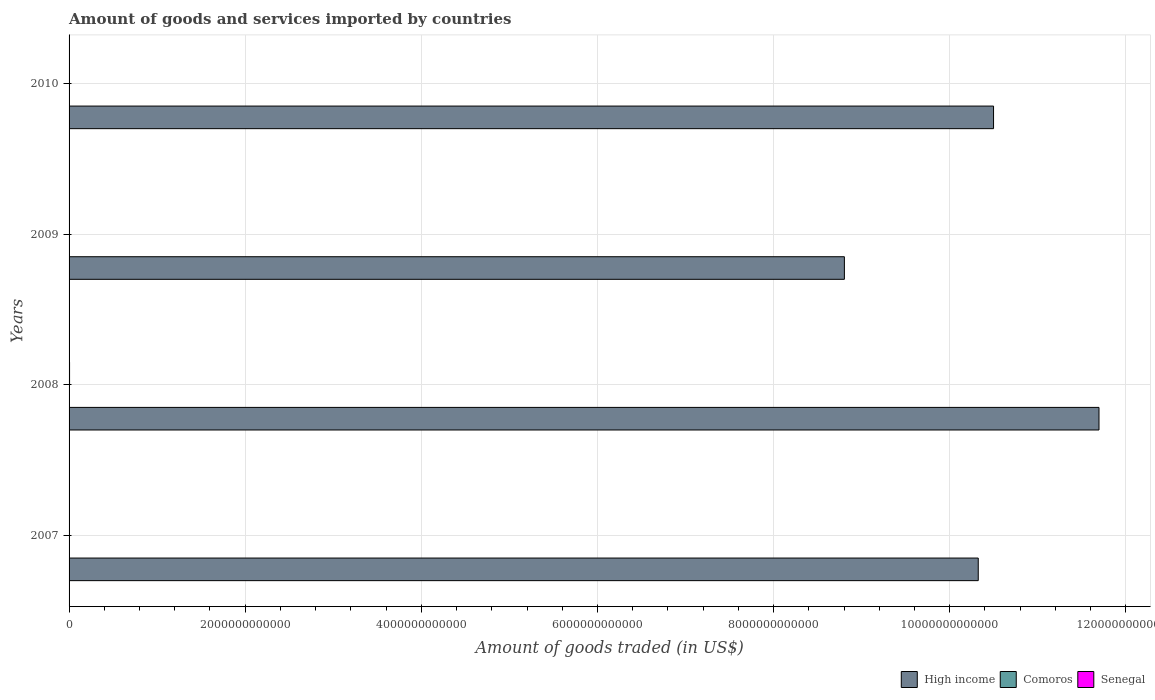How many groups of bars are there?
Provide a succinct answer. 4. Are the number of bars per tick equal to the number of legend labels?
Offer a terse response. Yes. How many bars are there on the 2nd tick from the top?
Make the answer very short. 3. What is the label of the 3rd group of bars from the top?
Provide a short and direct response. 2008. What is the total amount of goods and services imported in Comoros in 2010?
Offer a very short reply. 1.77e+08. Across all years, what is the maximum total amount of goods and services imported in High income?
Ensure brevity in your answer.  1.17e+13. Across all years, what is the minimum total amount of goods and services imported in Senegal?
Give a very brief answer. 4.08e+09. What is the total total amount of goods and services imported in High income in the graph?
Give a very brief answer. 4.13e+13. What is the difference between the total amount of goods and services imported in Senegal in 2007 and that in 2009?
Your response must be concise. 3.09e+07. What is the difference between the total amount of goods and services imported in Senegal in 2008 and the total amount of goods and services imported in Comoros in 2007?
Offer a terse response. 5.47e+09. What is the average total amount of goods and services imported in Senegal per year?
Provide a succinct answer. 4.49e+09. In the year 2008, what is the difference between the total amount of goods and services imported in Senegal and total amount of goods and services imported in High income?
Make the answer very short. -1.17e+13. What is the ratio of the total amount of goods and services imported in Comoros in 2008 to that in 2010?
Keep it short and to the point. 0.99. Is the total amount of goods and services imported in Senegal in 2007 less than that in 2009?
Offer a very short reply. No. What is the difference between the highest and the second highest total amount of goods and services imported in High income?
Keep it short and to the point. 1.20e+12. What is the difference between the highest and the lowest total amount of goods and services imported in Senegal?
Keep it short and to the point. 1.51e+09. In how many years, is the total amount of goods and services imported in Senegal greater than the average total amount of goods and services imported in Senegal taken over all years?
Ensure brevity in your answer.  1. Is the sum of the total amount of goods and services imported in Comoros in 2008 and 2010 greater than the maximum total amount of goods and services imported in Senegal across all years?
Provide a short and direct response. No. What does the 3rd bar from the top in 2010 represents?
Give a very brief answer. High income. How many bars are there?
Ensure brevity in your answer.  12. Are all the bars in the graph horizontal?
Your answer should be very brief. Yes. How many years are there in the graph?
Your answer should be compact. 4. What is the difference between two consecutive major ticks on the X-axis?
Your response must be concise. 2.00e+12. Are the values on the major ticks of X-axis written in scientific E-notation?
Give a very brief answer. No. Does the graph contain any zero values?
Your answer should be compact. No. Where does the legend appear in the graph?
Make the answer very short. Bottom right. How many legend labels are there?
Provide a succinct answer. 3. How are the legend labels stacked?
Your answer should be very brief. Horizontal. What is the title of the graph?
Keep it short and to the point. Amount of goods and services imported by countries. What is the label or title of the X-axis?
Give a very brief answer. Amount of goods traded (in US$). What is the label or title of the Y-axis?
Provide a succinct answer. Years. What is the Amount of goods traded (in US$) of High income in 2007?
Give a very brief answer. 1.03e+13. What is the Amount of goods traded (in US$) in Comoros in 2007?
Your answer should be compact. 1.28e+08. What is the Amount of goods traded (in US$) of Senegal in 2007?
Your response must be concise. 4.15e+09. What is the Amount of goods traded (in US$) in High income in 2008?
Your answer should be very brief. 1.17e+13. What is the Amount of goods traded (in US$) in Comoros in 2008?
Give a very brief answer. 1.76e+08. What is the Amount of goods traded (in US$) in Senegal in 2008?
Ensure brevity in your answer.  5.60e+09. What is the Amount of goods traded (in US$) of High income in 2009?
Give a very brief answer. 8.80e+12. What is the Amount of goods traded (in US$) in Comoros in 2009?
Your response must be concise. 1.70e+08. What is the Amount of goods traded (in US$) of Senegal in 2009?
Ensure brevity in your answer.  4.12e+09. What is the Amount of goods traded (in US$) of High income in 2010?
Your answer should be compact. 1.05e+13. What is the Amount of goods traded (in US$) in Comoros in 2010?
Your answer should be compact. 1.77e+08. What is the Amount of goods traded (in US$) of Senegal in 2010?
Keep it short and to the point. 4.08e+09. Across all years, what is the maximum Amount of goods traded (in US$) in High income?
Ensure brevity in your answer.  1.17e+13. Across all years, what is the maximum Amount of goods traded (in US$) of Comoros?
Your answer should be compact. 1.77e+08. Across all years, what is the maximum Amount of goods traded (in US$) of Senegal?
Your answer should be very brief. 5.60e+09. Across all years, what is the minimum Amount of goods traded (in US$) of High income?
Keep it short and to the point. 8.80e+12. Across all years, what is the minimum Amount of goods traded (in US$) of Comoros?
Provide a short and direct response. 1.28e+08. Across all years, what is the minimum Amount of goods traded (in US$) in Senegal?
Your answer should be compact. 4.08e+09. What is the total Amount of goods traded (in US$) of High income in the graph?
Offer a terse response. 4.13e+13. What is the total Amount of goods traded (in US$) of Comoros in the graph?
Make the answer very short. 6.51e+08. What is the total Amount of goods traded (in US$) in Senegal in the graph?
Provide a short and direct response. 1.80e+1. What is the difference between the Amount of goods traded (in US$) of High income in 2007 and that in 2008?
Provide a succinct answer. -1.37e+12. What is the difference between the Amount of goods traded (in US$) in Comoros in 2007 and that in 2008?
Give a very brief answer. -4.80e+07. What is the difference between the Amount of goods traded (in US$) in Senegal in 2007 and that in 2008?
Offer a very short reply. -1.44e+09. What is the difference between the Amount of goods traded (in US$) in High income in 2007 and that in 2009?
Provide a short and direct response. 1.52e+12. What is the difference between the Amount of goods traded (in US$) of Comoros in 2007 and that in 2009?
Your answer should be very brief. -4.17e+07. What is the difference between the Amount of goods traded (in US$) in Senegal in 2007 and that in 2009?
Your response must be concise. 3.09e+07. What is the difference between the Amount of goods traded (in US$) in High income in 2007 and that in 2010?
Provide a succinct answer. -1.74e+11. What is the difference between the Amount of goods traded (in US$) of Comoros in 2007 and that in 2010?
Offer a terse response. -4.95e+07. What is the difference between the Amount of goods traded (in US$) of Senegal in 2007 and that in 2010?
Your response must be concise. 7.14e+07. What is the difference between the Amount of goods traded (in US$) of High income in 2008 and that in 2009?
Give a very brief answer. 2.89e+12. What is the difference between the Amount of goods traded (in US$) of Comoros in 2008 and that in 2009?
Ensure brevity in your answer.  6.33e+06. What is the difference between the Amount of goods traded (in US$) in Senegal in 2008 and that in 2009?
Ensure brevity in your answer.  1.47e+09. What is the difference between the Amount of goods traded (in US$) in High income in 2008 and that in 2010?
Make the answer very short. 1.20e+12. What is the difference between the Amount of goods traded (in US$) of Comoros in 2008 and that in 2010?
Provide a succinct answer. -1.45e+06. What is the difference between the Amount of goods traded (in US$) in Senegal in 2008 and that in 2010?
Offer a terse response. 1.51e+09. What is the difference between the Amount of goods traded (in US$) of High income in 2009 and that in 2010?
Ensure brevity in your answer.  -1.69e+12. What is the difference between the Amount of goods traded (in US$) of Comoros in 2009 and that in 2010?
Give a very brief answer. -7.79e+06. What is the difference between the Amount of goods traded (in US$) in Senegal in 2009 and that in 2010?
Keep it short and to the point. 4.05e+07. What is the difference between the Amount of goods traded (in US$) in High income in 2007 and the Amount of goods traded (in US$) in Comoros in 2008?
Your answer should be compact. 1.03e+13. What is the difference between the Amount of goods traded (in US$) of High income in 2007 and the Amount of goods traded (in US$) of Senegal in 2008?
Make the answer very short. 1.03e+13. What is the difference between the Amount of goods traded (in US$) of Comoros in 2007 and the Amount of goods traded (in US$) of Senegal in 2008?
Give a very brief answer. -5.47e+09. What is the difference between the Amount of goods traded (in US$) of High income in 2007 and the Amount of goods traded (in US$) of Comoros in 2009?
Make the answer very short. 1.03e+13. What is the difference between the Amount of goods traded (in US$) in High income in 2007 and the Amount of goods traded (in US$) in Senegal in 2009?
Provide a short and direct response. 1.03e+13. What is the difference between the Amount of goods traded (in US$) of Comoros in 2007 and the Amount of goods traded (in US$) of Senegal in 2009?
Your response must be concise. -3.99e+09. What is the difference between the Amount of goods traded (in US$) in High income in 2007 and the Amount of goods traded (in US$) in Comoros in 2010?
Keep it short and to the point. 1.03e+13. What is the difference between the Amount of goods traded (in US$) of High income in 2007 and the Amount of goods traded (in US$) of Senegal in 2010?
Keep it short and to the point. 1.03e+13. What is the difference between the Amount of goods traded (in US$) of Comoros in 2007 and the Amount of goods traded (in US$) of Senegal in 2010?
Give a very brief answer. -3.95e+09. What is the difference between the Amount of goods traded (in US$) of High income in 2008 and the Amount of goods traded (in US$) of Comoros in 2009?
Your answer should be very brief. 1.17e+13. What is the difference between the Amount of goods traded (in US$) of High income in 2008 and the Amount of goods traded (in US$) of Senegal in 2009?
Ensure brevity in your answer.  1.17e+13. What is the difference between the Amount of goods traded (in US$) in Comoros in 2008 and the Amount of goods traded (in US$) in Senegal in 2009?
Provide a succinct answer. -3.95e+09. What is the difference between the Amount of goods traded (in US$) in High income in 2008 and the Amount of goods traded (in US$) in Comoros in 2010?
Provide a short and direct response. 1.17e+13. What is the difference between the Amount of goods traded (in US$) of High income in 2008 and the Amount of goods traded (in US$) of Senegal in 2010?
Offer a very short reply. 1.17e+13. What is the difference between the Amount of goods traded (in US$) of Comoros in 2008 and the Amount of goods traded (in US$) of Senegal in 2010?
Offer a very short reply. -3.91e+09. What is the difference between the Amount of goods traded (in US$) of High income in 2009 and the Amount of goods traded (in US$) of Comoros in 2010?
Keep it short and to the point. 8.80e+12. What is the difference between the Amount of goods traded (in US$) of High income in 2009 and the Amount of goods traded (in US$) of Senegal in 2010?
Give a very brief answer. 8.80e+12. What is the difference between the Amount of goods traded (in US$) in Comoros in 2009 and the Amount of goods traded (in US$) in Senegal in 2010?
Keep it short and to the point. -3.91e+09. What is the average Amount of goods traded (in US$) in High income per year?
Provide a succinct answer. 1.03e+13. What is the average Amount of goods traded (in US$) of Comoros per year?
Your answer should be compact. 1.63e+08. What is the average Amount of goods traded (in US$) of Senegal per year?
Your answer should be compact. 4.49e+09. In the year 2007, what is the difference between the Amount of goods traded (in US$) of High income and Amount of goods traded (in US$) of Comoros?
Make the answer very short. 1.03e+13. In the year 2007, what is the difference between the Amount of goods traded (in US$) in High income and Amount of goods traded (in US$) in Senegal?
Provide a short and direct response. 1.03e+13. In the year 2007, what is the difference between the Amount of goods traded (in US$) of Comoros and Amount of goods traded (in US$) of Senegal?
Provide a short and direct response. -4.03e+09. In the year 2008, what is the difference between the Amount of goods traded (in US$) in High income and Amount of goods traded (in US$) in Comoros?
Your response must be concise. 1.17e+13. In the year 2008, what is the difference between the Amount of goods traded (in US$) of High income and Amount of goods traded (in US$) of Senegal?
Your answer should be very brief. 1.17e+13. In the year 2008, what is the difference between the Amount of goods traded (in US$) in Comoros and Amount of goods traded (in US$) in Senegal?
Offer a terse response. -5.42e+09. In the year 2009, what is the difference between the Amount of goods traded (in US$) in High income and Amount of goods traded (in US$) in Comoros?
Your response must be concise. 8.80e+12. In the year 2009, what is the difference between the Amount of goods traded (in US$) of High income and Amount of goods traded (in US$) of Senegal?
Provide a succinct answer. 8.80e+12. In the year 2009, what is the difference between the Amount of goods traded (in US$) in Comoros and Amount of goods traded (in US$) in Senegal?
Offer a very short reply. -3.95e+09. In the year 2010, what is the difference between the Amount of goods traded (in US$) in High income and Amount of goods traded (in US$) in Comoros?
Offer a very short reply. 1.05e+13. In the year 2010, what is the difference between the Amount of goods traded (in US$) in High income and Amount of goods traded (in US$) in Senegal?
Give a very brief answer. 1.05e+13. In the year 2010, what is the difference between the Amount of goods traded (in US$) of Comoros and Amount of goods traded (in US$) of Senegal?
Your answer should be compact. -3.91e+09. What is the ratio of the Amount of goods traded (in US$) of High income in 2007 to that in 2008?
Your answer should be very brief. 0.88. What is the ratio of the Amount of goods traded (in US$) of Comoros in 2007 to that in 2008?
Offer a terse response. 0.73. What is the ratio of the Amount of goods traded (in US$) in Senegal in 2007 to that in 2008?
Give a very brief answer. 0.74. What is the ratio of the Amount of goods traded (in US$) of High income in 2007 to that in 2009?
Offer a very short reply. 1.17. What is the ratio of the Amount of goods traded (in US$) of Comoros in 2007 to that in 2009?
Your response must be concise. 0.75. What is the ratio of the Amount of goods traded (in US$) of Senegal in 2007 to that in 2009?
Your answer should be very brief. 1.01. What is the ratio of the Amount of goods traded (in US$) of High income in 2007 to that in 2010?
Keep it short and to the point. 0.98. What is the ratio of the Amount of goods traded (in US$) of Comoros in 2007 to that in 2010?
Offer a terse response. 0.72. What is the ratio of the Amount of goods traded (in US$) of Senegal in 2007 to that in 2010?
Keep it short and to the point. 1.02. What is the ratio of the Amount of goods traded (in US$) in High income in 2008 to that in 2009?
Your answer should be very brief. 1.33. What is the ratio of the Amount of goods traded (in US$) in Comoros in 2008 to that in 2009?
Your answer should be very brief. 1.04. What is the ratio of the Amount of goods traded (in US$) in Senegal in 2008 to that in 2009?
Your answer should be very brief. 1.36. What is the ratio of the Amount of goods traded (in US$) in High income in 2008 to that in 2010?
Make the answer very short. 1.11. What is the ratio of the Amount of goods traded (in US$) in Senegal in 2008 to that in 2010?
Ensure brevity in your answer.  1.37. What is the ratio of the Amount of goods traded (in US$) in High income in 2009 to that in 2010?
Provide a succinct answer. 0.84. What is the ratio of the Amount of goods traded (in US$) in Comoros in 2009 to that in 2010?
Your response must be concise. 0.96. What is the ratio of the Amount of goods traded (in US$) of Senegal in 2009 to that in 2010?
Keep it short and to the point. 1.01. What is the difference between the highest and the second highest Amount of goods traded (in US$) in High income?
Keep it short and to the point. 1.20e+12. What is the difference between the highest and the second highest Amount of goods traded (in US$) in Comoros?
Ensure brevity in your answer.  1.45e+06. What is the difference between the highest and the second highest Amount of goods traded (in US$) of Senegal?
Offer a very short reply. 1.44e+09. What is the difference between the highest and the lowest Amount of goods traded (in US$) in High income?
Offer a very short reply. 2.89e+12. What is the difference between the highest and the lowest Amount of goods traded (in US$) of Comoros?
Ensure brevity in your answer.  4.95e+07. What is the difference between the highest and the lowest Amount of goods traded (in US$) in Senegal?
Provide a short and direct response. 1.51e+09. 